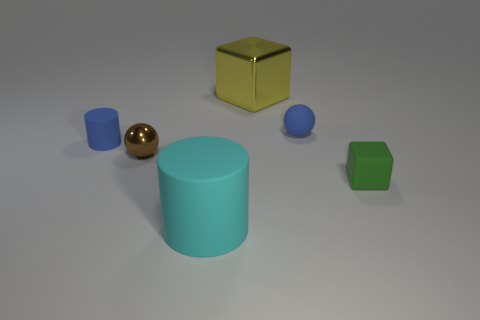What number of other objects are the same shape as the tiny brown object?
Keep it short and to the point. 1. What color is the matte cylinder that is the same size as the yellow metallic thing?
Make the answer very short. Cyan. Are there any large cyan rubber cylinders?
Offer a terse response. Yes. There is a large object behind the large cyan rubber cylinder; what shape is it?
Offer a very short reply. Cube. How many objects are in front of the green matte thing and behind the green cube?
Give a very brief answer. 0. Is there a object that has the same material as the small brown sphere?
Make the answer very short. Yes. What number of balls are big green metallic objects or yellow metal objects?
Provide a succinct answer. 0. What size is the cyan rubber cylinder?
Keep it short and to the point. Large. How many brown spheres are in front of the small cube?
Provide a short and direct response. 0. What is the size of the shiny cube behind the cylinder that is in front of the green thing?
Make the answer very short. Large. 